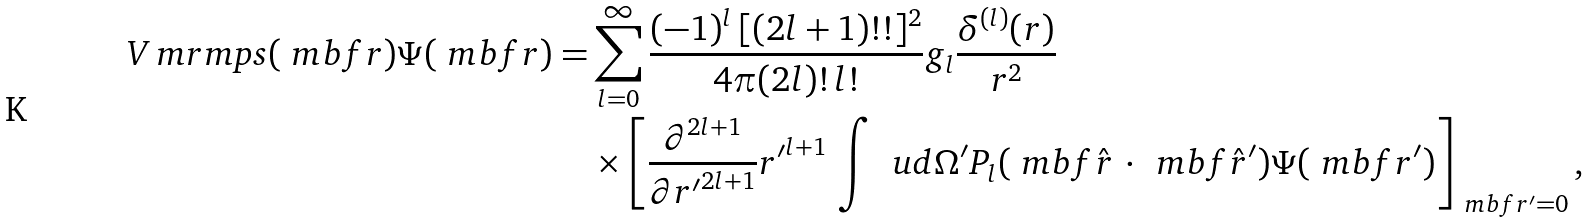<formula> <loc_0><loc_0><loc_500><loc_500>V _ { \ } m r m { p s } ( \ m b f { r } ) \Psi ( \ m b f { r } ) = & \sum _ { l = 0 } ^ { \infty } \frac { ( - 1 ) ^ { l } \, [ ( 2 l + 1 ) ! ! ] ^ { 2 } } { 4 \pi ( 2 l ) ! \, l ! } g _ { l } \frac { \delta ^ { ( l ) } ( r ) } { r ^ { 2 } } \\ & \times \left [ \frac { \partial ^ { 2 l + 1 } } { \partial { r ^ { \prime } } ^ { 2 l + 1 } } { r ^ { \prime } } ^ { l + 1 } \, \int \, \ u d \Omega ^ { \prime } P _ { l } ( \ m b f { \hat { r } } \, \cdot \, \ m b f { \hat { r } } ^ { \prime } ) \Psi ( \ m b f { r } ^ { \prime } ) \right ] _ { \ m b f { r } ^ { \prime } = 0 } ,</formula> 